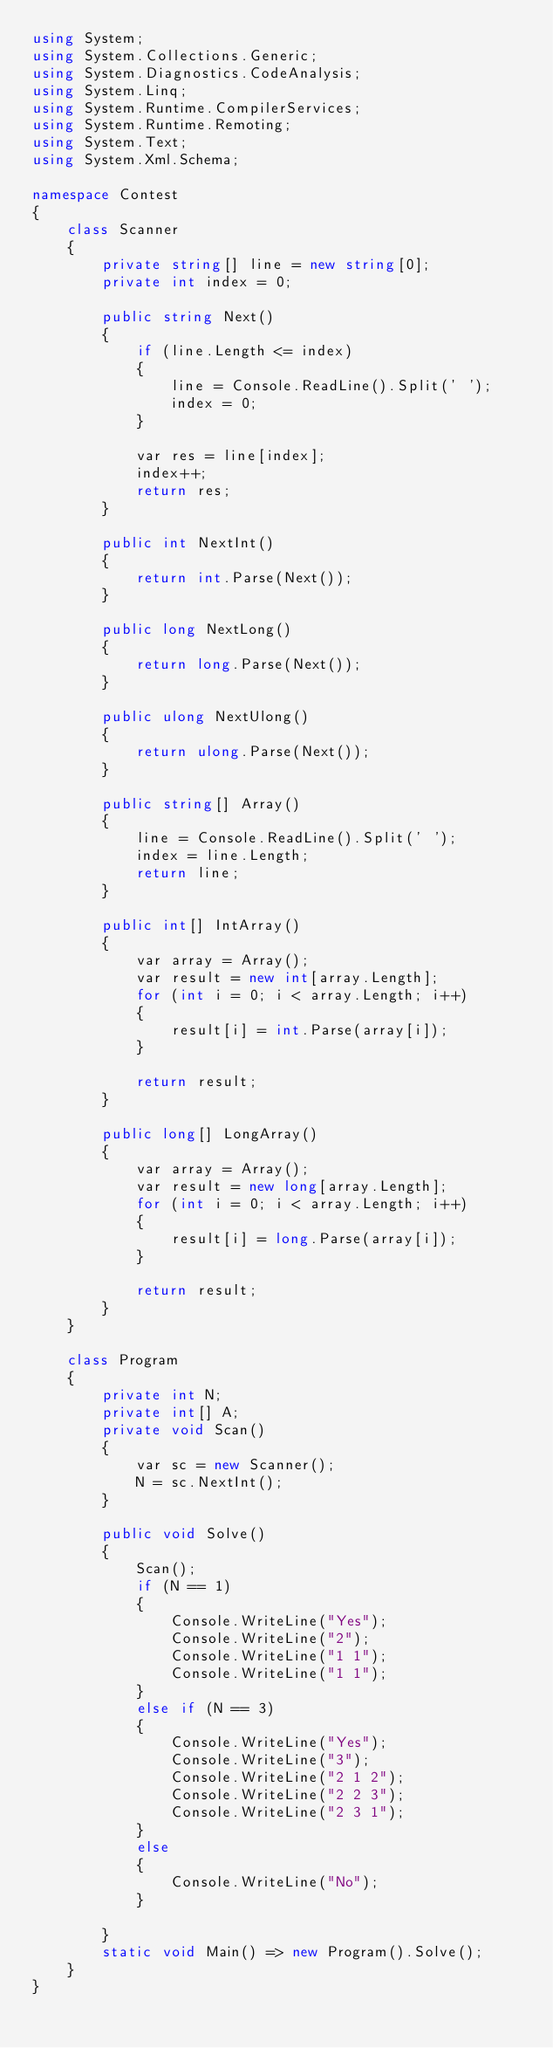<code> <loc_0><loc_0><loc_500><loc_500><_C#_>using System;
using System.Collections.Generic;
using System.Diagnostics.CodeAnalysis;
using System.Linq;
using System.Runtime.CompilerServices;
using System.Runtime.Remoting;
using System.Text;
using System.Xml.Schema;

namespace Contest
{
    class Scanner
    {
        private string[] line = new string[0];
        private int index = 0;

        public string Next()
        {
            if (line.Length <= index)
            {
                line = Console.ReadLine().Split(' ');
                index = 0;
            }

            var res = line[index];
            index++;
            return res;
        }

        public int NextInt()
        {
            return int.Parse(Next());
        }

        public long NextLong()
        {
            return long.Parse(Next());
        }

        public ulong NextUlong()
        {
            return ulong.Parse(Next());
        }

        public string[] Array()
        {
            line = Console.ReadLine().Split(' ');
            index = line.Length;
            return line;
        }

        public int[] IntArray()
        {
            var array = Array();
            var result = new int[array.Length];
            for (int i = 0; i < array.Length; i++)
            {
                result[i] = int.Parse(array[i]);
            }

            return result;
        }

        public long[] LongArray()
        {
            var array = Array();
            var result = new long[array.Length];
            for (int i = 0; i < array.Length; i++)
            {
                result[i] = long.Parse(array[i]);
            }

            return result;
        }
    }

    class Program
    {
        private int N;
        private int[] A;
        private void Scan()
        {
            var sc = new Scanner();
            N = sc.NextInt();
        }

        public void Solve()
        {
            Scan();
            if (N == 1)
            {
                Console.WriteLine("Yes");
                Console.WriteLine("2");
                Console.WriteLine("1 1");
                Console.WriteLine("1 1");
            }
            else if (N == 3)
            {
                Console.WriteLine("Yes");
                Console.WriteLine("3");
                Console.WriteLine("2 1 2");
                Console.WriteLine("2 2 3");
                Console.WriteLine("2 3 1");
            }
            else
            {
                Console.WriteLine("No");
            }

        }
        static void Main() => new Program().Solve();
    }
}</code> 